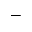<formula> <loc_0><loc_0><loc_500><loc_500>-</formula> 